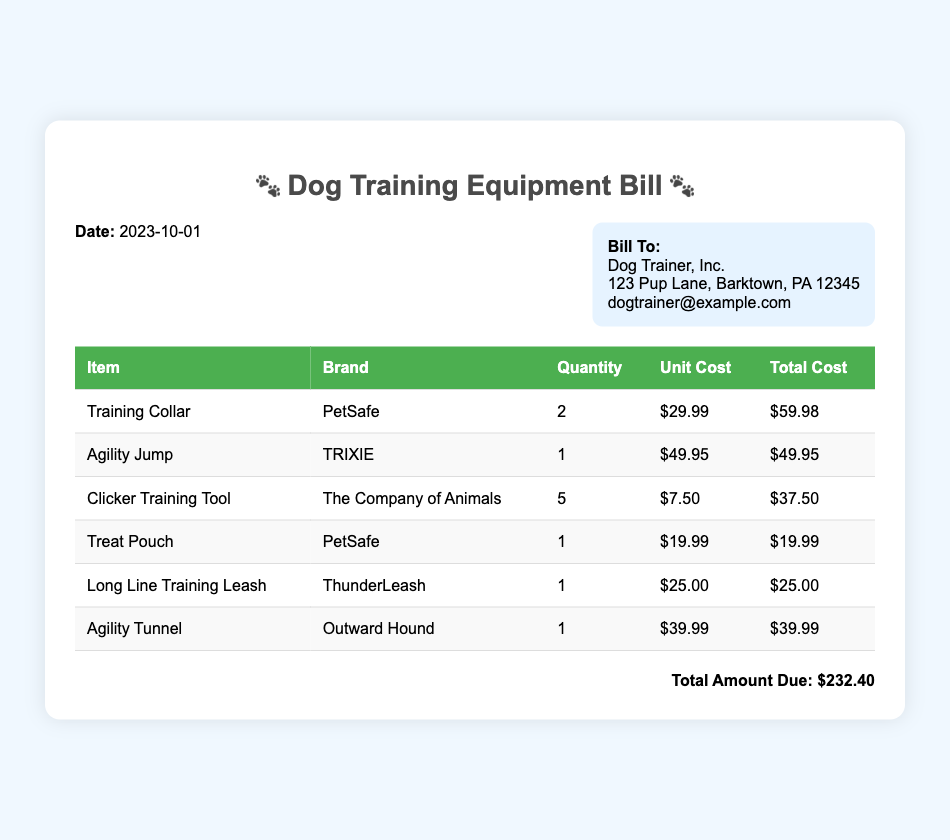What is the date of the bill? The date of the bill is stated prominently at the top of the document.
Answer: 2023-10-01 What is the name of the company that the bill is addressed to? The bill is directed to an entity, mentioned in the "Bill To" section of the document.
Answer: Dog Trainer, Inc How many Training Collars were purchased? The quantity of Training Collars can be found in the table of items.
Answer: 2 What is the total amount due? The total amount due is displayed at the bottom of the bill, summarizing the total cost of all items.
Answer: $232.40 Which brand makes the Agility Tunnel? The brand associated with the Agility Tunnel can be found in the itemized table.
Answer: Outward Hound What is the unit cost of the Clicker Training Tool? The unit cost for the Clicker Training Tool is indicated in the corresponding table row.
Answer: $7.50 How many items are listed in the bill? By counting the number of rows in the itemized list, one can determine the total items purchased.
Answer: 6 What is the total cost of the Treat Pouch? The total cost for the Treat Pouch can be directly derived from the item's entry in the list.
Answer: $19.99 